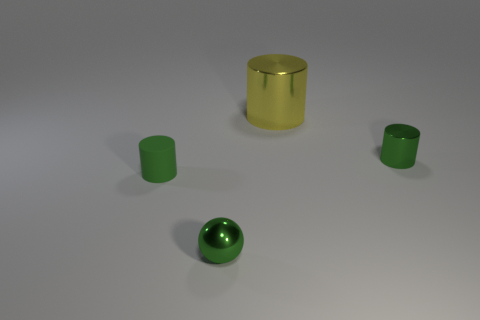Are there any other things that have the same size as the yellow metallic cylinder?
Make the answer very short. No. Are there any green shiny objects to the left of the small green rubber cylinder?
Your answer should be very brief. No. There is a yellow metal thing that is the same shape as the tiny green matte thing; what is its size?
Give a very brief answer. Large. Are there the same number of small green objects behind the green matte cylinder and objects in front of the metal ball?
Your response must be concise. No. How many green balls are there?
Offer a very short reply. 1. Are there more small metallic objects behind the large metallic thing than small cylinders?
Provide a succinct answer. No. There is a object that is in front of the green matte thing; what is its material?
Keep it short and to the point. Metal. The big metallic object that is the same shape as the tiny rubber object is what color?
Provide a succinct answer. Yellow. What number of tiny rubber cylinders are the same color as the tiny metal sphere?
Keep it short and to the point. 1. There is a cylinder on the left side of the tiny green sphere; does it have the same size as the green metallic object that is in front of the green metallic cylinder?
Offer a very short reply. Yes. 